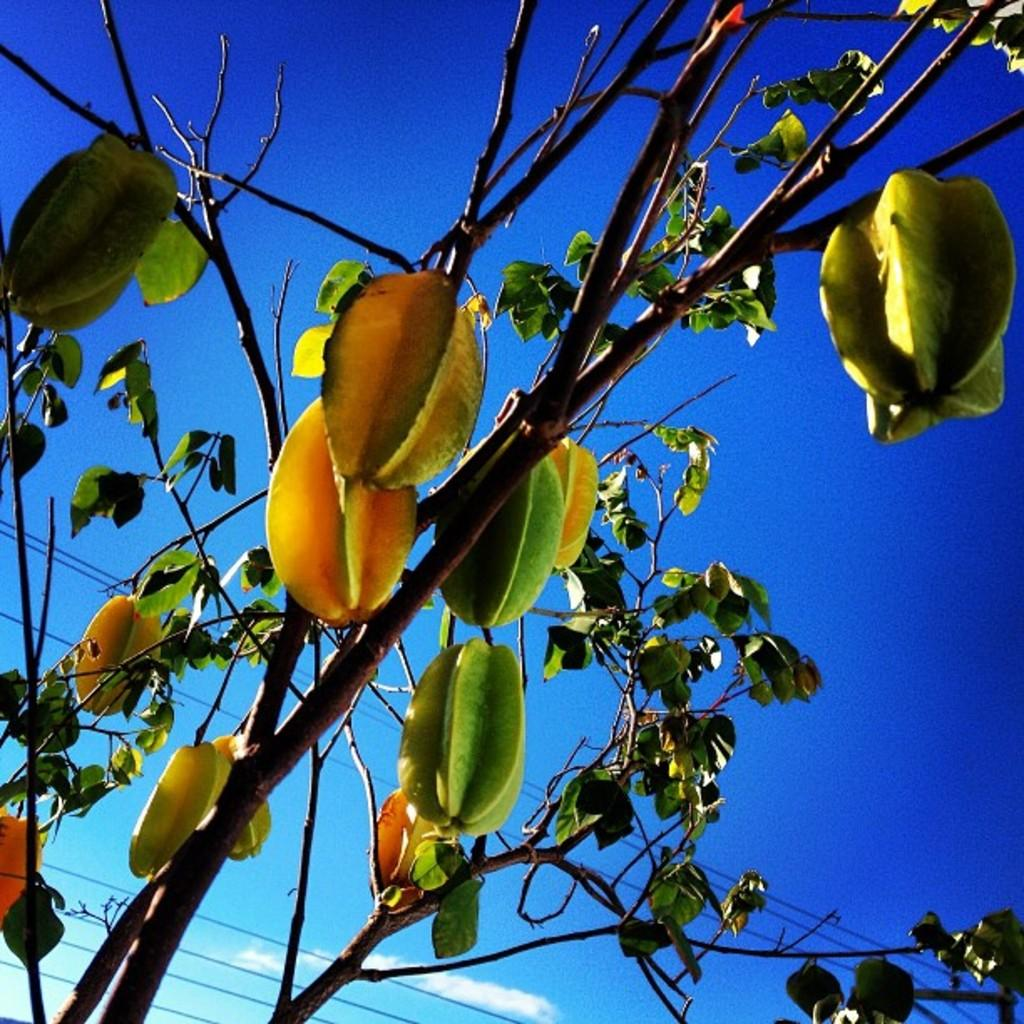What can be seen in the foreground of the picture? There are branches, leaves, and fruits in the foreground of the picture. What is visible in the background of the picture? The sky is visible in the background of the picture. What can be found at the bottom of the picture? There are cables at the bottom of the picture. How many slaves are depicted in the picture? There are no slaves present in the picture. What type of crayon can be seen in the picture? There are no crayons present in the picture. 